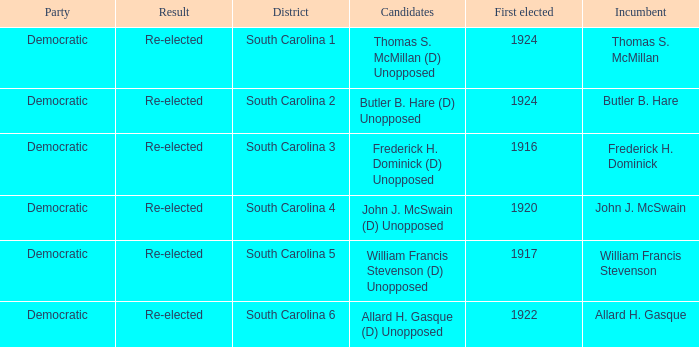What year was william francis stevenson first elected? 1917.0. 